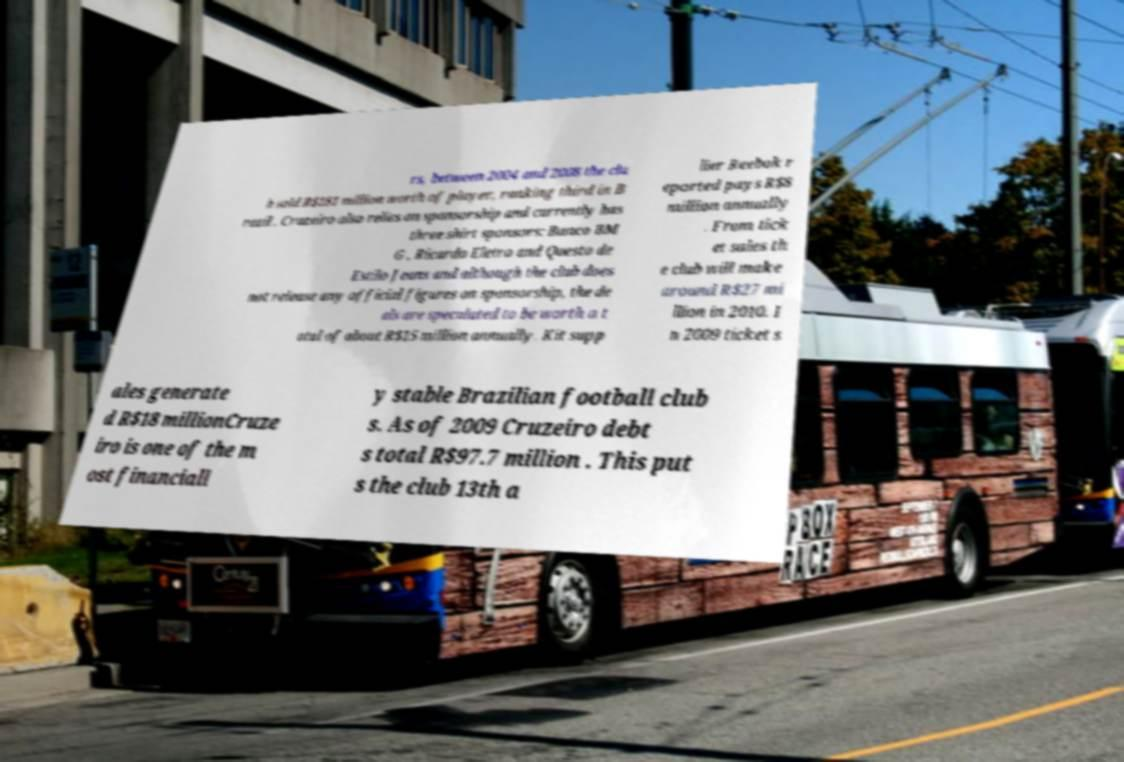Can you accurately transcribe the text from the provided image for me? rs, between 2004 and 2008 the clu b sold R$181 million worth of player, ranking third in B razil . Cruzeiro also relies on sponsorship and currently has three shirt sponsors: Banco BM G , Ricardo Eletro and Questo de Estilo Jeans and although the club does not release any official figures on sponsorship, the de als are speculated to be worth a t otal of about R$15 million annually. Kit supp lier Reebok r eported pays R$8 million annually . From tick et sales th e club will make around R$27 mi llion in 2010. I n 2009 ticket s ales generate d R$18 millionCruze iro is one of the m ost financiall y stable Brazilian football club s. As of 2009 Cruzeiro debt s total R$97.7 million . This put s the club 13th a 